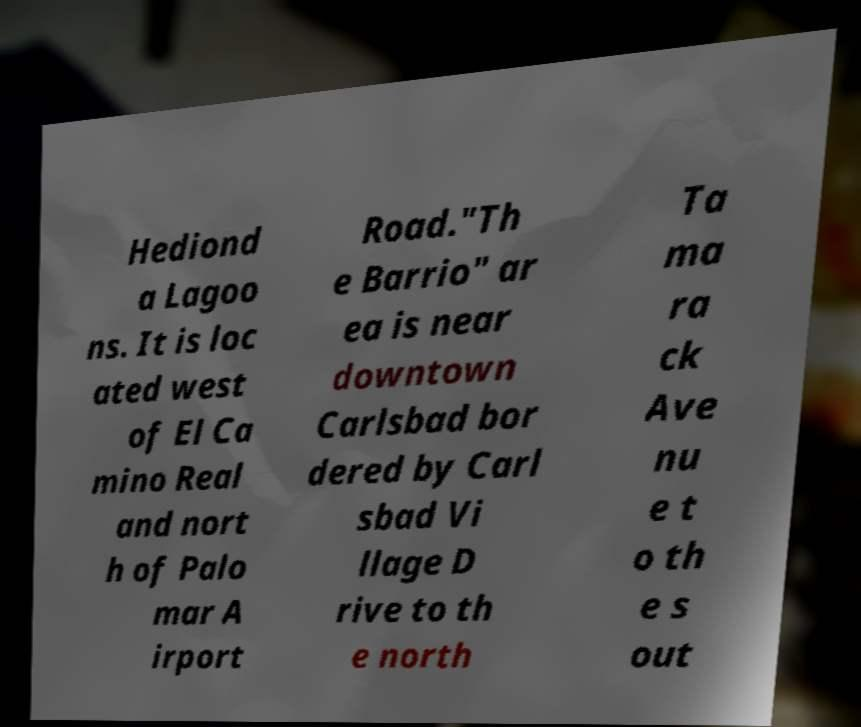Can you read and provide the text displayed in the image?This photo seems to have some interesting text. Can you extract and type it out for me? Hediond a Lagoo ns. It is loc ated west of El Ca mino Real and nort h of Palo mar A irport Road."Th e Barrio" ar ea is near downtown Carlsbad bor dered by Carl sbad Vi llage D rive to th e north Ta ma ra ck Ave nu e t o th e s out 